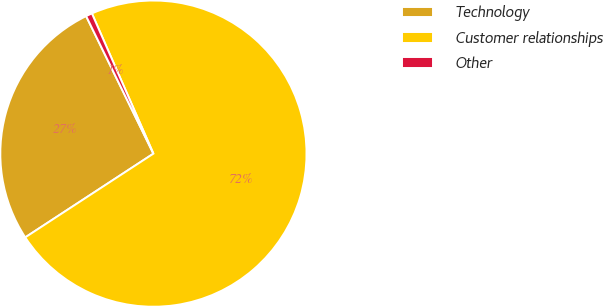Convert chart to OTSL. <chart><loc_0><loc_0><loc_500><loc_500><pie_chart><fcel>Technology<fcel>Customer relationships<fcel>Other<nl><fcel>26.97%<fcel>72.37%<fcel>0.66%<nl></chart> 